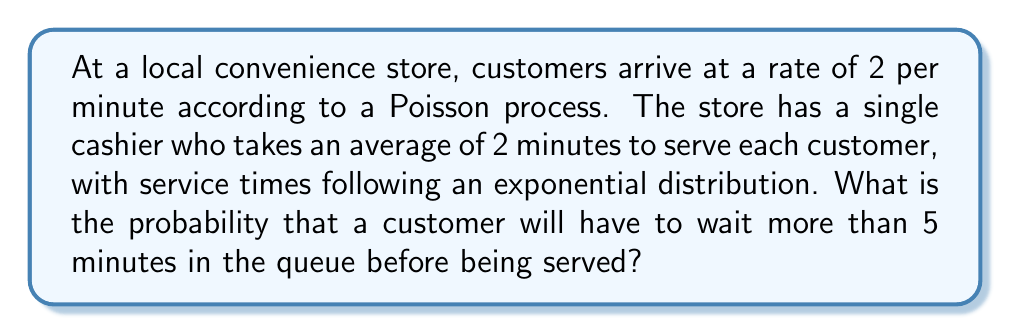Can you solve this math problem? Let's approach this step-by-step:

1) First, we need to identify the type of queueing system. This is an M/M/1 queue, where:
   - M: Arrivals follow a Markov (Poisson) process
   - M: Service times are Markovian (exponentially distributed)
   - 1: There is one server

2) We need to calculate the utilization factor $\rho$:
   $\rho = \frac{\lambda}{\mu}$
   where $\lambda$ is the arrival rate and $\mu$ is the service rate.

   $\lambda = 2$ customers/minute
   $\mu = \frac{1}{2} = 0.5$ customers/minute

   $\rho = \frac{2}{0.5} = 4$

3) Since $\rho > 1$, the queue is unstable and will grow indefinitely. In a real-world scenario, this would lead to an ever-increasing queue length.

4) For an M/M/1 queue, the waiting time follows an exponential distribution with parameter $\mu(1-\rho)$. However, this is only valid for $\rho < 1$.

5) In this unstable case, as time goes to infinity, the probability of waiting more than any fixed time approaches 1.

6) Therefore, in the long run, the probability that a customer will have to wait more than 5 minutes is 1.
Answer: 1 